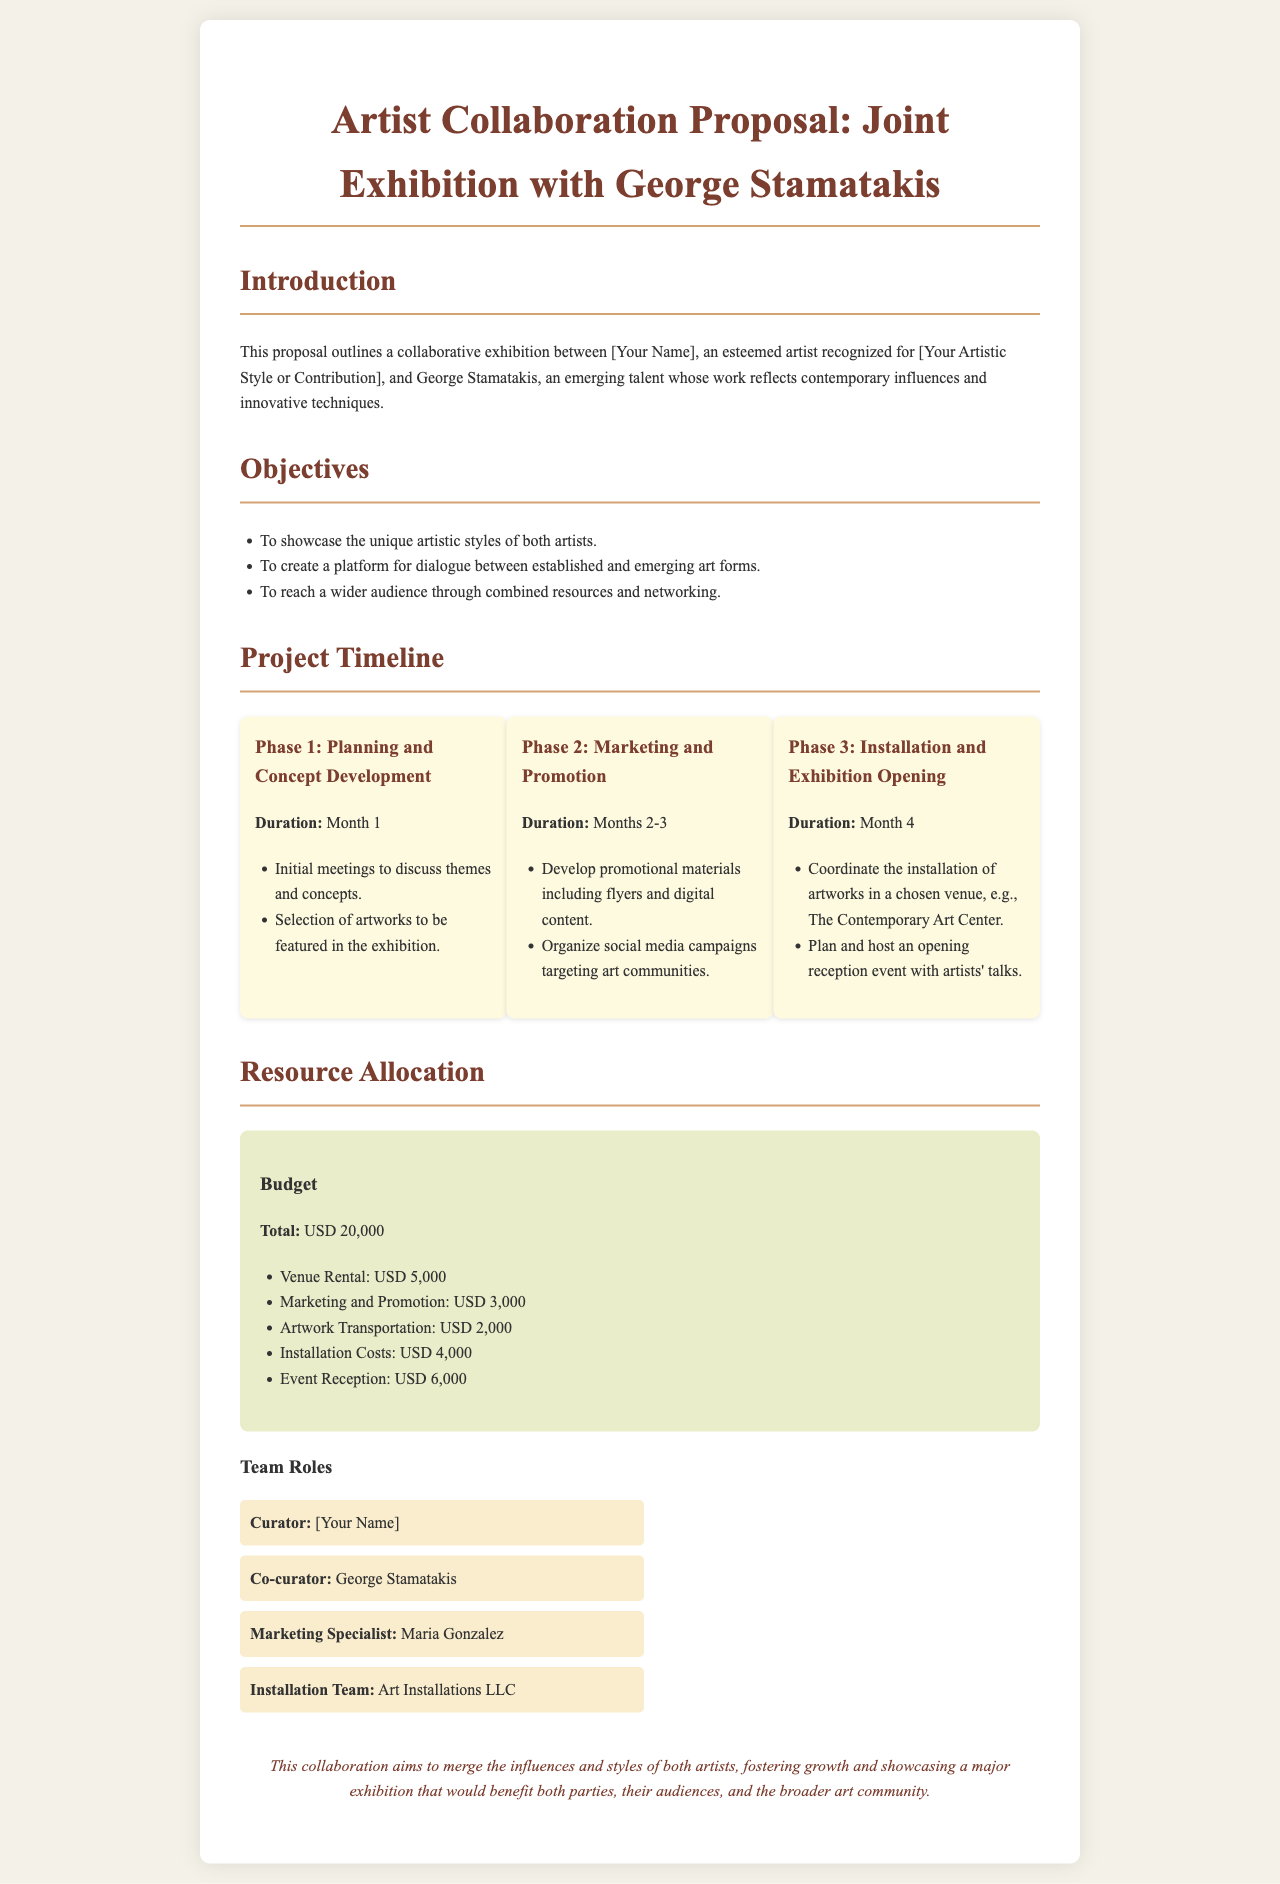what is the title of the proposal? The title of the proposal is stated at the beginning of the document, which is "Artist Collaboration Proposal: Joint Exhibition with George Stamatakis."
Answer: Artist Collaboration Proposal: Joint Exhibition with George Stamatakis how many phases are there in the project timeline? The project timeline is divided into three phases as listed in the document.
Answer: 3 what is the budget for marketing and promotion? The budget for marketing and promotion is specified in the resource allocation section of the document.
Answer: USD 3,000 who is the co-curator of the exhibition? The document specifies the co-curator role and identifies George Stamatakis.
Answer: George Stamatakis what is the duration of Phase 2: Marketing and Promotion? The duration for Phase 2 is mentioned directly in the timeline section.
Answer: Months 2-3 what is the total budget for the project? The total budget is clearly stated in the resource allocation section of the document.
Answer: USD 20,000 what venue is suggested for the exhibition? The suggested venue is mentioned during the installation phase in the timeline.
Answer: The Contemporary Art Center what is the primary objective of the joint exhibition? The objectives section lists the goals of the exhibition, focusing on showcasing artistic styles.
Answer: To showcase the unique artistic styles of both artists who is responsible for installation? The installation team is specified in the team roles section of the document.
Answer: Art Installations LLC 